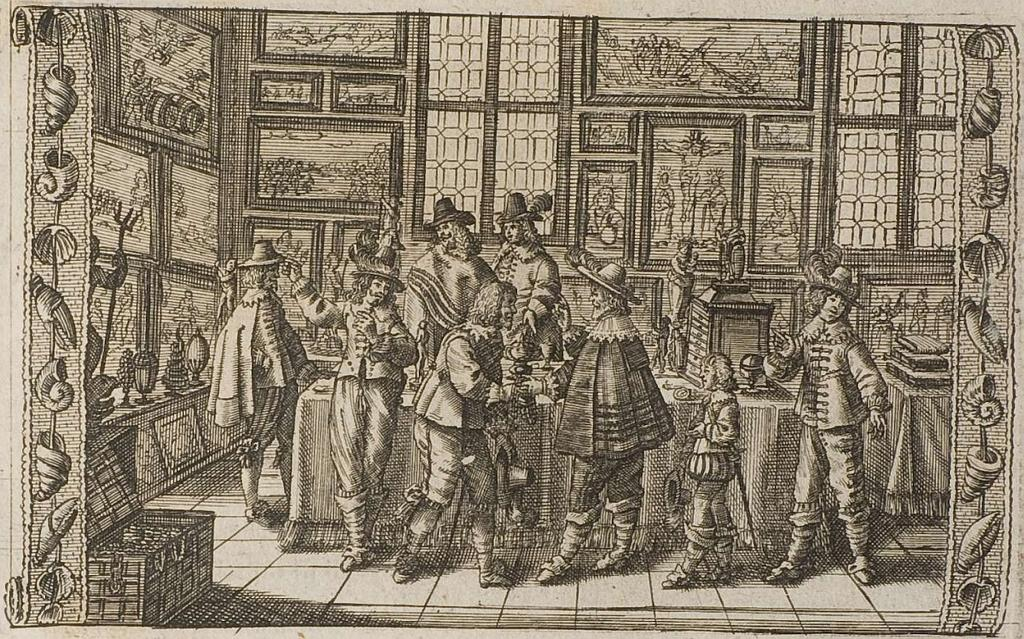What type of object is the main subject of the image? A: The image contains an art piece. What can be seen within the art piece? The art piece includes person images. What is the background setting of the image? There is a wall visible in the image, and a window is also present. Are there any other decorative items in the image? Yes, photo frames are present in the image. What type of furniture is visible in the image? A table is visible in the image. Are there any other objects in the image? Yes, there is a box in the image. Did the art piece cause an earthquake in the image? There is no indication of an earthquake in the image, and the art piece does not cause any natural disasters. 